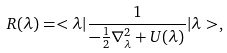<formula> <loc_0><loc_0><loc_500><loc_500>R ( \lambda ) = < \lambda | \frac { 1 } { - \frac { 1 } { 2 } \nabla _ { \lambda } ^ { 2 } + U ( \lambda ) } | \lambda > ,</formula> 